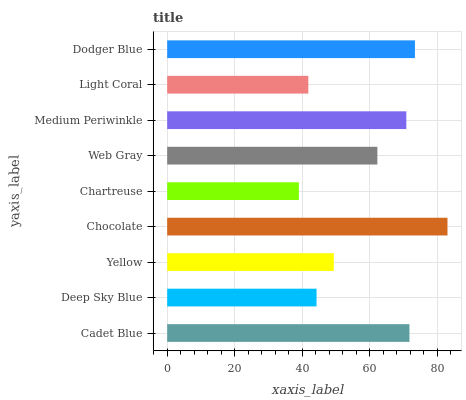Is Chartreuse the minimum?
Answer yes or no. Yes. Is Chocolate the maximum?
Answer yes or no. Yes. Is Deep Sky Blue the minimum?
Answer yes or no. No. Is Deep Sky Blue the maximum?
Answer yes or no. No. Is Cadet Blue greater than Deep Sky Blue?
Answer yes or no. Yes. Is Deep Sky Blue less than Cadet Blue?
Answer yes or no. Yes. Is Deep Sky Blue greater than Cadet Blue?
Answer yes or no. No. Is Cadet Blue less than Deep Sky Blue?
Answer yes or no. No. Is Web Gray the high median?
Answer yes or no. Yes. Is Web Gray the low median?
Answer yes or no. Yes. Is Chartreuse the high median?
Answer yes or no. No. Is Dodger Blue the low median?
Answer yes or no. No. 